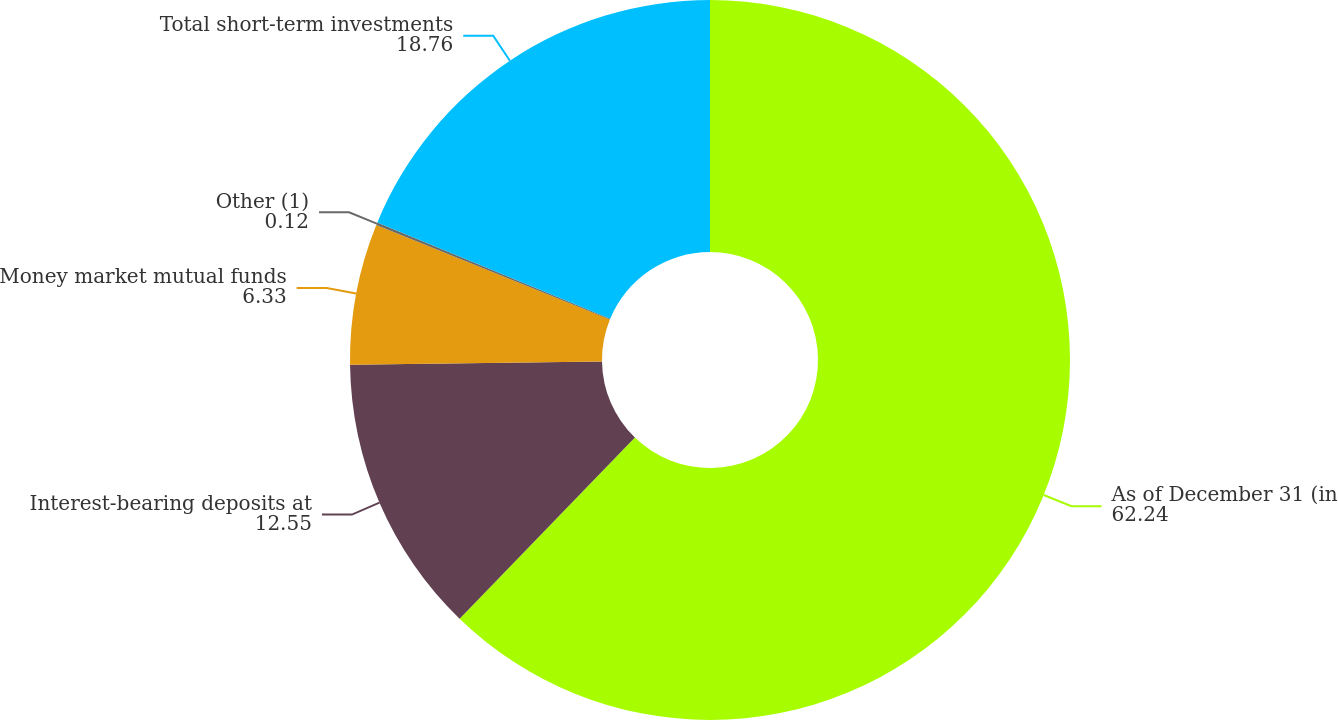<chart> <loc_0><loc_0><loc_500><loc_500><pie_chart><fcel>As of December 31 (in<fcel>Interest-bearing deposits at<fcel>Money market mutual funds<fcel>Other (1)<fcel>Total short-term investments<nl><fcel>62.24%<fcel>12.55%<fcel>6.33%<fcel>0.12%<fcel>18.76%<nl></chart> 